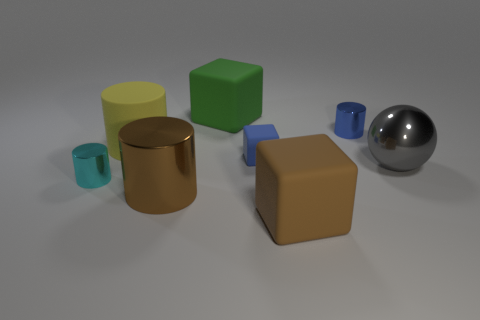Is the number of big brown rubber things that are behind the blue block less than the number of big brown matte things?
Your answer should be very brief. Yes. There is a big block that is in front of the green matte block; what color is it?
Your answer should be compact. Brown. The large thing that is in front of the large metallic object on the left side of the blue matte cube is made of what material?
Ensure brevity in your answer.  Rubber. Is there a sphere that has the same size as the rubber cylinder?
Offer a very short reply. Yes. How many objects are tiny cyan cylinders that are on the left side of the big green block or rubber blocks that are in front of the yellow matte thing?
Provide a short and direct response. 3. Do the shiny cylinder behind the small cyan thing and the block in front of the small cyan metallic thing have the same size?
Provide a short and direct response. No. There is a tiny metal cylinder that is to the left of the small blue shiny thing; is there a rubber thing behind it?
Provide a short and direct response. Yes. There is a yellow rubber object; how many green matte objects are on the left side of it?
Your answer should be very brief. 0. How many other objects are there of the same color as the large metallic cylinder?
Your response must be concise. 1. Are there fewer large gray metal spheres on the right side of the metal sphere than small rubber objects that are on the right side of the tiny blue cube?
Give a very brief answer. No. 